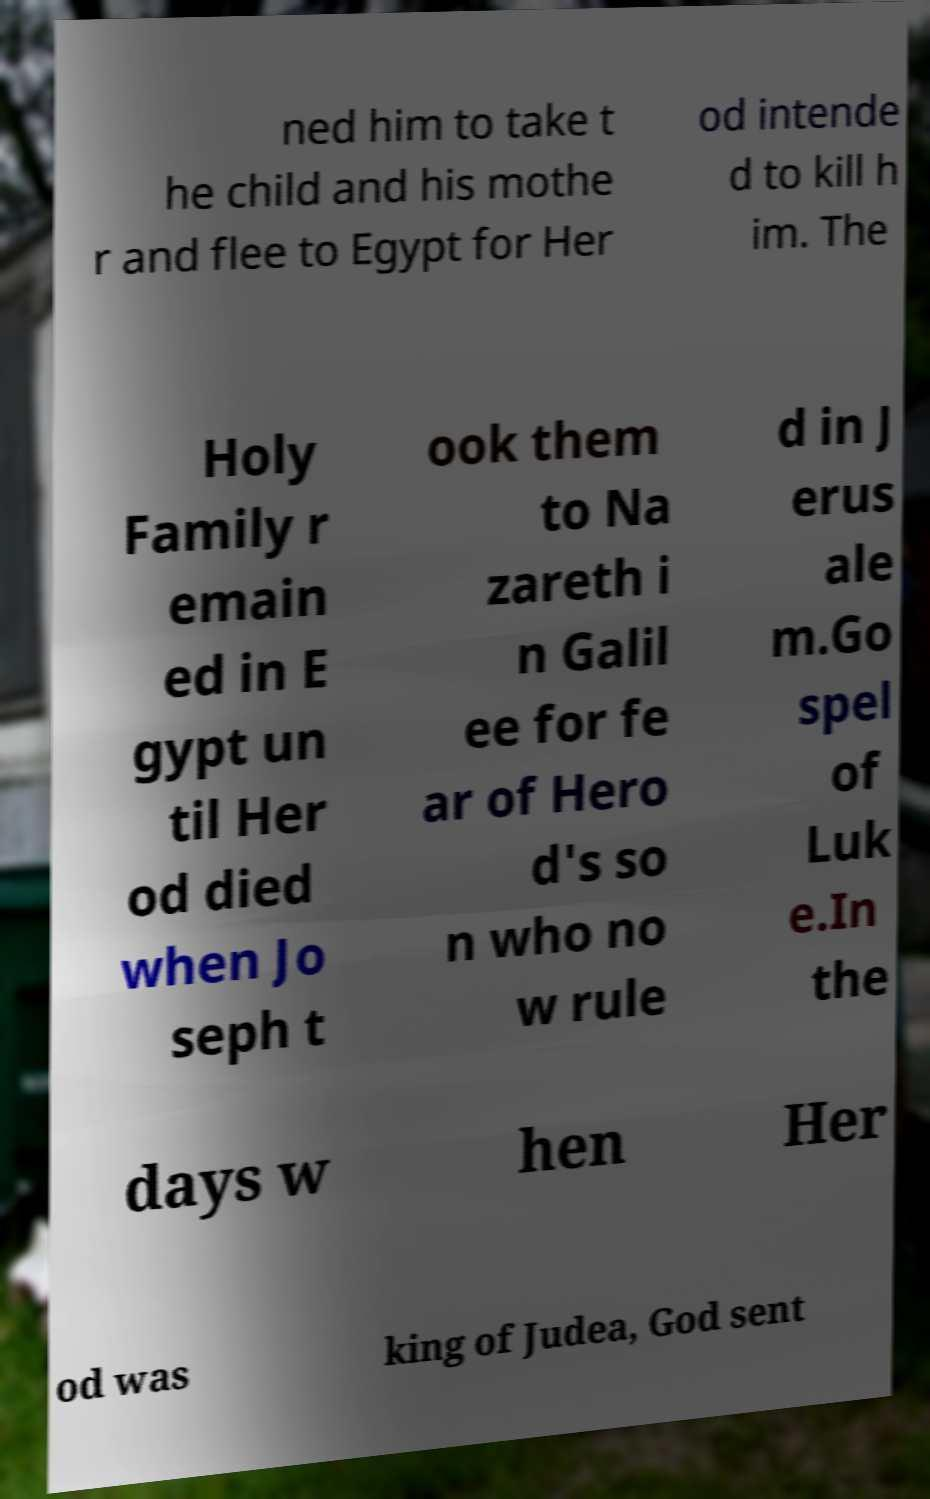I need the written content from this picture converted into text. Can you do that? ned him to take t he child and his mothe r and flee to Egypt for Her od intende d to kill h im. The Holy Family r emain ed in E gypt un til Her od died when Jo seph t ook them to Na zareth i n Galil ee for fe ar of Hero d's so n who no w rule d in J erus ale m.Go spel of Luk e.In the days w hen Her od was king of Judea, God sent 